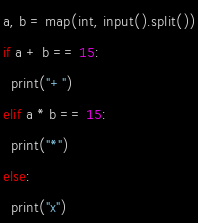Convert code to text. <code><loc_0><loc_0><loc_500><loc_500><_Python_>a, b = map(int, input().split())
if a + b == 15:
  print("+")
elif a * b == 15:
  print("*")
else:
  print("x")</code> 